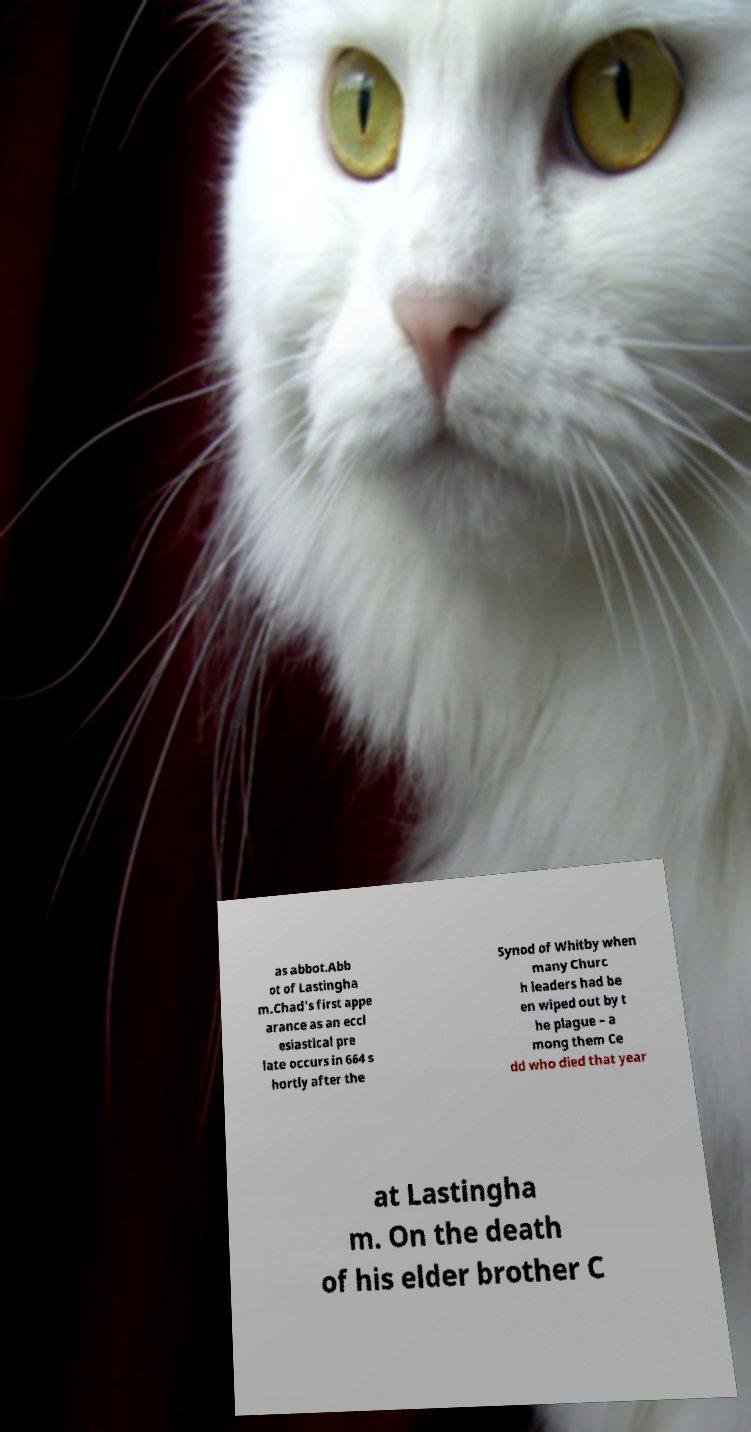I need the written content from this picture converted into text. Can you do that? as abbot.Abb ot of Lastingha m.Chad's first appe arance as an eccl esiastical pre late occurs in 664 s hortly after the Synod of Whitby when many Churc h leaders had be en wiped out by t he plague – a mong them Ce dd who died that year at Lastingha m. On the death of his elder brother C 